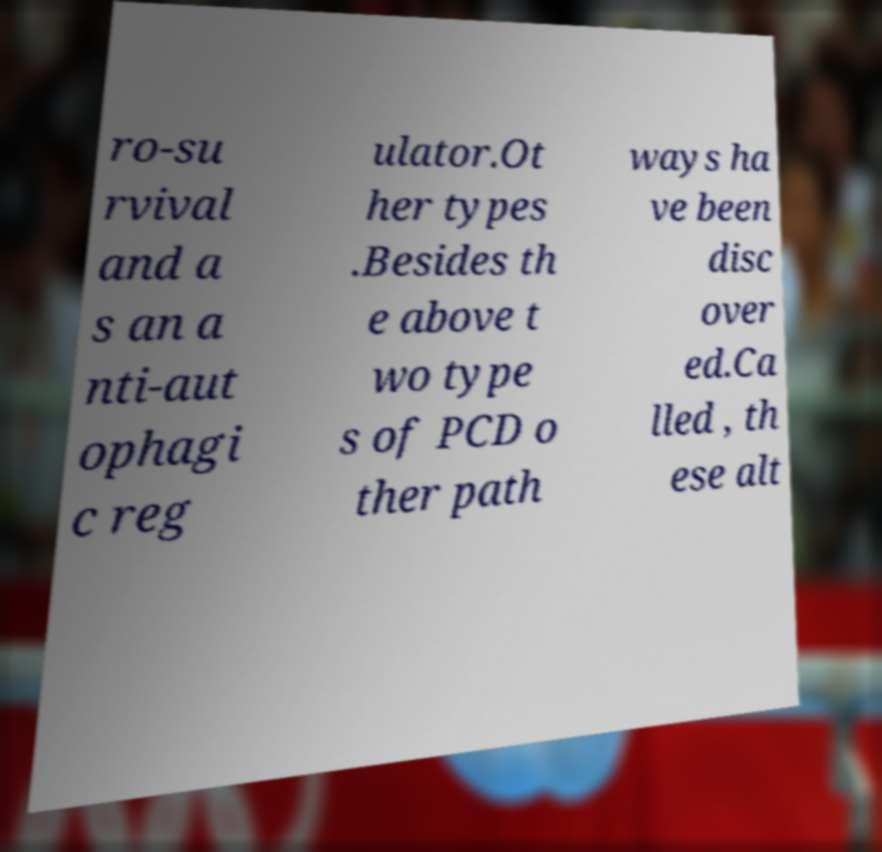Could you assist in decoding the text presented in this image and type it out clearly? ro-su rvival and a s an a nti-aut ophagi c reg ulator.Ot her types .Besides th e above t wo type s of PCD o ther path ways ha ve been disc over ed.Ca lled , th ese alt 